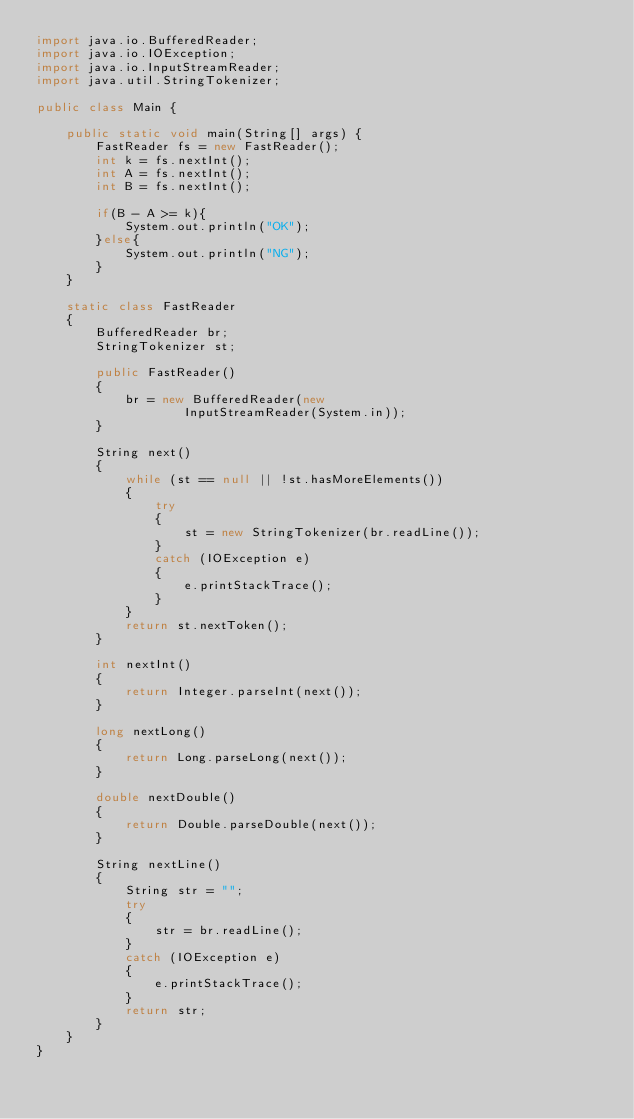Convert code to text. <code><loc_0><loc_0><loc_500><loc_500><_Java_>import java.io.BufferedReader;
import java.io.IOException;
import java.io.InputStreamReader;
import java.util.StringTokenizer;

public class Main {

    public static void main(String[] args) {
        FastReader fs = new FastReader();
        int k = fs.nextInt();
        int A = fs.nextInt();
        int B = fs.nextInt();

        if(B - A >= k){
            System.out.println("OK");
        }else{
            System.out.println("NG");
        }
    }

    static class FastReader
    {
        BufferedReader br;
        StringTokenizer st;

        public FastReader()
        {
            br = new BufferedReader(new
                    InputStreamReader(System.in));
        }

        String next()
        {
            while (st == null || !st.hasMoreElements())
            {
                try
                {
                    st = new StringTokenizer(br.readLine());
                }
                catch (IOException e)
                {
                    e.printStackTrace();
                }
            }
            return st.nextToken();
        }

        int nextInt()
        {
            return Integer.parseInt(next());
        }

        long nextLong()
        {
            return Long.parseLong(next());
        }

        double nextDouble()
        {
            return Double.parseDouble(next());
        }

        String nextLine()
        {
            String str = "";
            try
            {
                str = br.readLine();
            }
            catch (IOException e)
            {
                e.printStackTrace();
            }
            return str;
        }
    }
}
</code> 